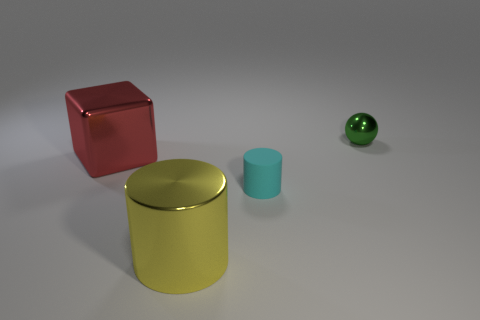Are there any blue cubes?
Your response must be concise. No. There is a cylinder left of the small object in front of the big red cube; how big is it?
Offer a very short reply. Large. Is there a blue object made of the same material as the small cyan object?
Make the answer very short. No. What is the material of the cylinder that is the same size as the red block?
Your response must be concise. Metal. There is a large object behind the big shiny cylinder; are there any cyan rubber things right of it?
Give a very brief answer. Yes. There is a shiny thing in front of the large block; is it the same shape as the small thing left of the tiny metal ball?
Your answer should be compact. Yes. Do the big object that is on the right side of the large red cube and the small object in front of the red object have the same material?
Your answer should be very brief. No. There is a small thing in front of the shiny object that is right of the yellow object; what is its material?
Keep it short and to the point. Rubber. What is the shape of the metal object that is behind the large object behind the large metallic thing that is right of the big red object?
Give a very brief answer. Sphere. What is the material of the other large object that is the same shape as the cyan object?
Provide a succinct answer. Metal. 